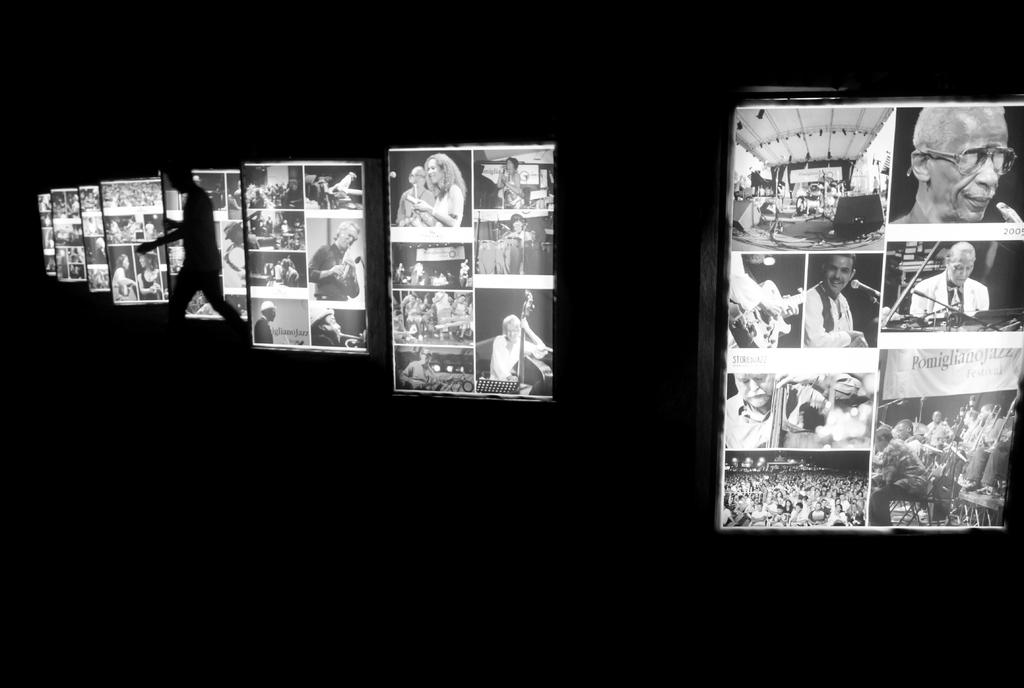What is the color scheme of the image? The image is black and white. Can you describe the main subject in the image? There is a person in the image. What else can be seen in the image besides the person? There are boards with people and other objects in the image. What type of jam is being spread on the boards in the image? There is no jam present in the image; it is a black and white image with a person and boards with people and other objects. 